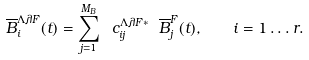Convert formula to latex. <formula><loc_0><loc_0><loc_500><loc_500>\overline { B } _ { i } ^ { \Lambda \lambda F } ( t ) = \sum _ { j = 1 } ^ { M _ { B } } \ c ^ { \Lambda \lambda F \ast } _ { i j } \ \overline { B } ^ { F } _ { j } ( t ) , \quad i = 1 \dots r .</formula> 